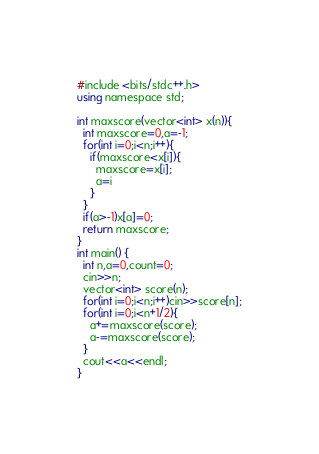<code> <loc_0><loc_0><loc_500><loc_500><_C#_>#include <bits/stdc++.h>
using namespace std;

int maxscore(vector<int> x(n)){
  int maxscore=0,a=-1;
  for(int i=0;i<n;i++){
    if(maxscore<x[i]){
      maxscore=x[i];
      a=i
    }
  }
  if(a>-1)x[a]=0;
  return maxscore;
}
int main() {
  int n,a=0,count=0;
  cin>>n;
  vector<int> score(n);
  for(int i=0;i<n;i++)cin>>score[n];
  for(int i=0;i<n+1/2){
    a+=maxscore(score);
    a-=maxscore(score);
  }
  cout<<a<<endl;
}</code> 